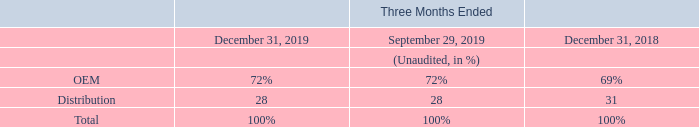Original Equipment Manufacturers (“OEM”) are the end-customers to which we provide direct marketing application engineering support, while Distribution customers refers to the distributors and representatives that we engage to distribute our products around the world.
By market channel, our fourth quarter revenues in Distribution amounted to 28% of our total revenues, flat compared to the previous quarter and decreasing on a year-over-year basis.
What are Original Equipment Manufacturers? Original equipment manufacturers (“oem”) are the end-customers to which we provide direct marketing application engineering support. What are Distribution customers? Distribution customers refers to the distributors and representatives that we engage to distribute our products around the world. How much did the Distribution accounted for in the fourth quarter of total revenues? 28%. What is the average net revenues from OEM for the period December 31, 2019 and 2018?
Answer scale should be: percent. (72+69) / 2
Answer: 70.5. What is the average net revenues from Distribution for the period December 31, 2019 and 2018?
Answer scale should be: percent. (28+31) / 2
Answer: 29.5. What is the increase/ (decrease) in OEM from the period December 31, 2018 to 2019?
Answer scale should be: percent. 72-69
Answer: 3. 